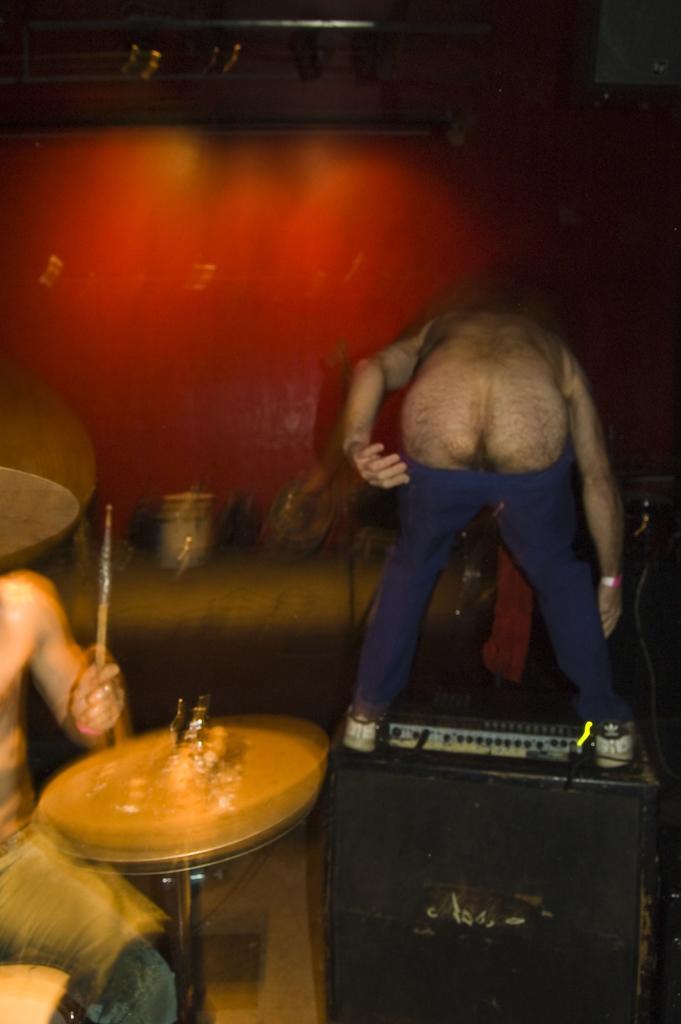How would you summarize this image in a sentence or two? A person is playing drums at the right. A person is bending wearing a blue trouser. The background is blurred. 